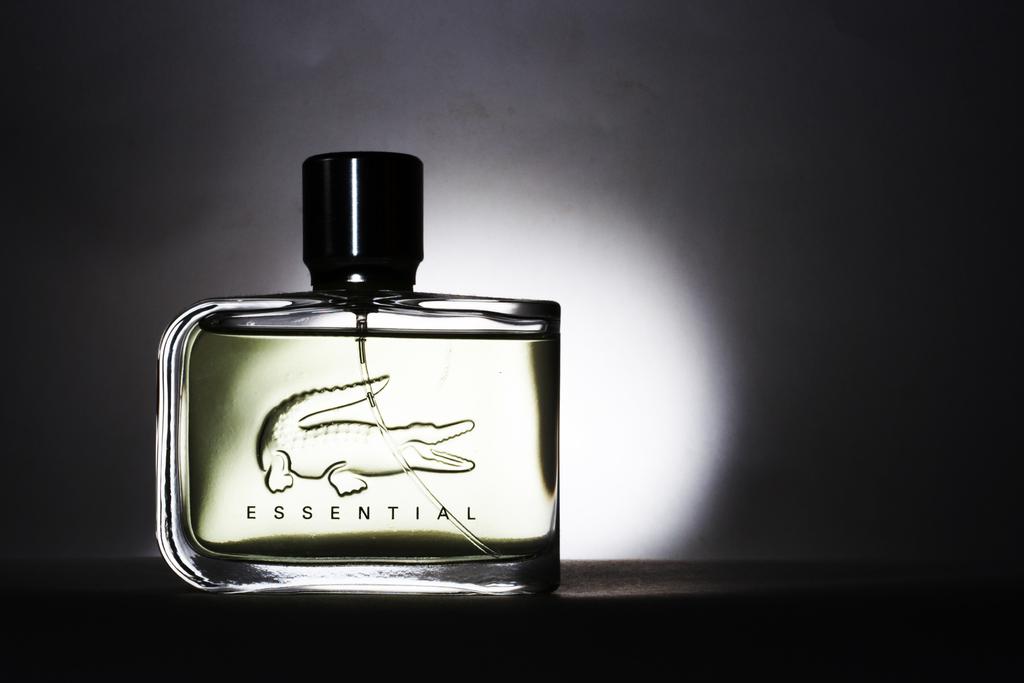What is the name of this cologne?
Give a very brief answer. Essential. 